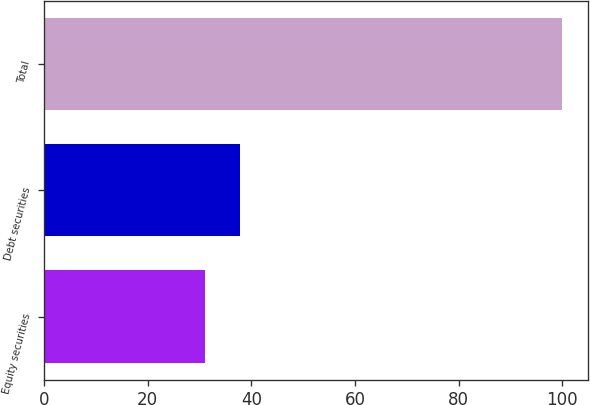<chart> <loc_0><loc_0><loc_500><loc_500><bar_chart><fcel>Equity securities<fcel>Debt securities<fcel>Total<nl><fcel>31<fcel>37.9<fcel>100<nl></chart> 